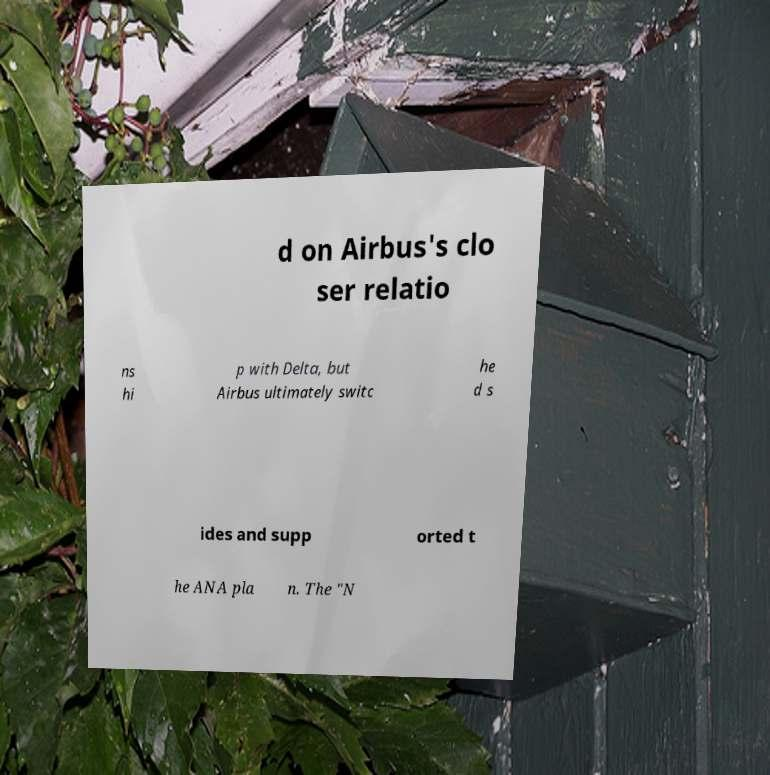Please read and relay the text visible in this image. What does it say? d on Airbus's clo ser relatio ns hi p with Delta, but Airbus ultimately switc he d s ides and supp orted t he ANA pla n. The "N 